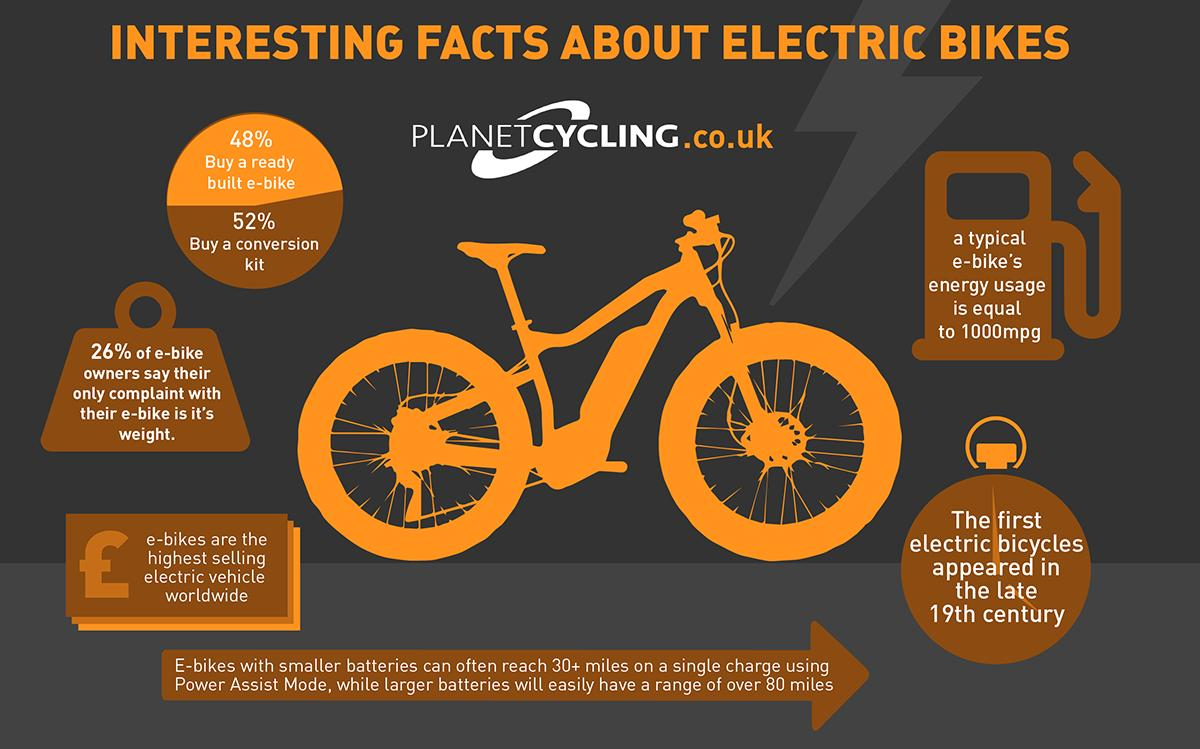Highlight a few significant elements in this photo. A significant percentage of people do not purchase a pre-built electric bike, with 52% being the specific number. 